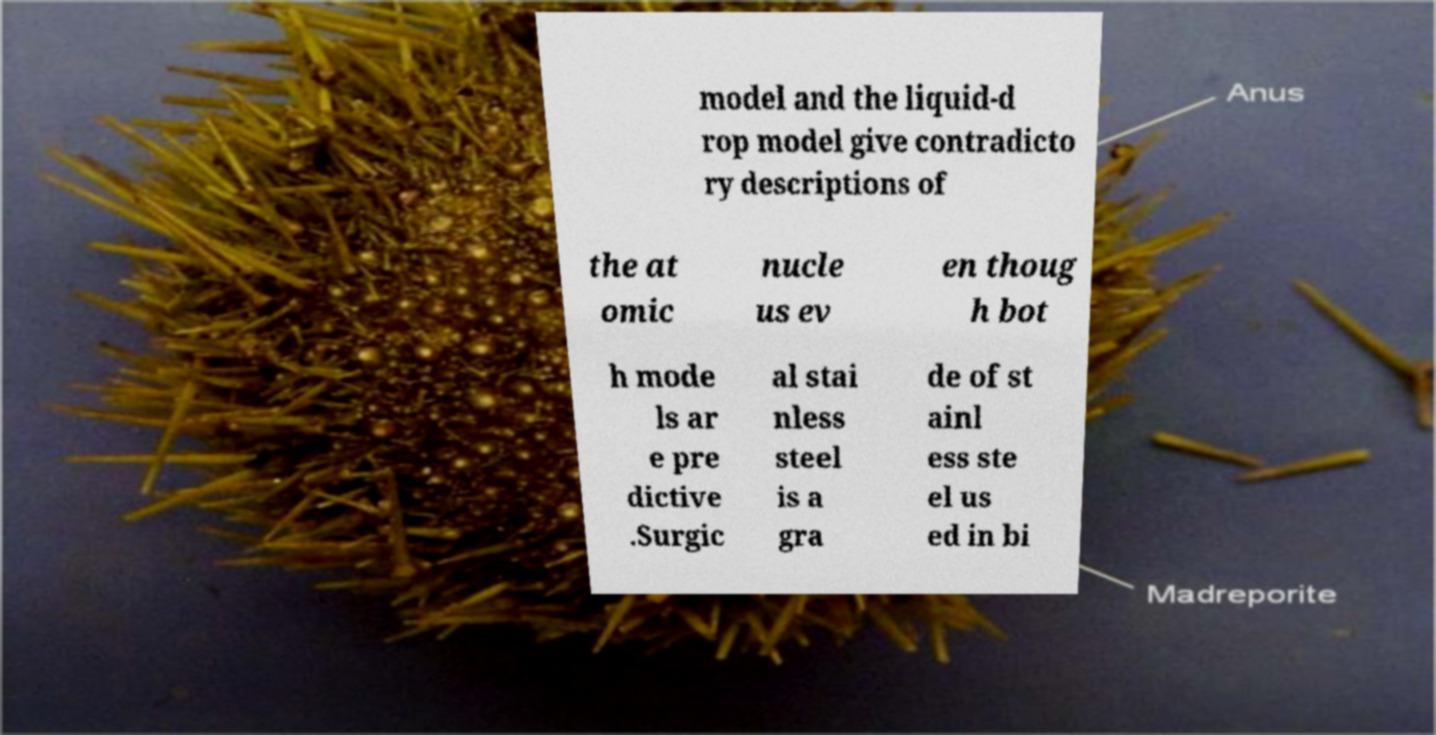There's text embedded in this image that I need extracted. Can you transcribe it verbatim? model and the liquid-d rop model give contradicto ry descriptions of the at omic nucle us ev en thoug h bot h mode ls ar e pre dictive .Surgic al stai nless steel is a gra de of st ainl ess ste el us ed in bi 